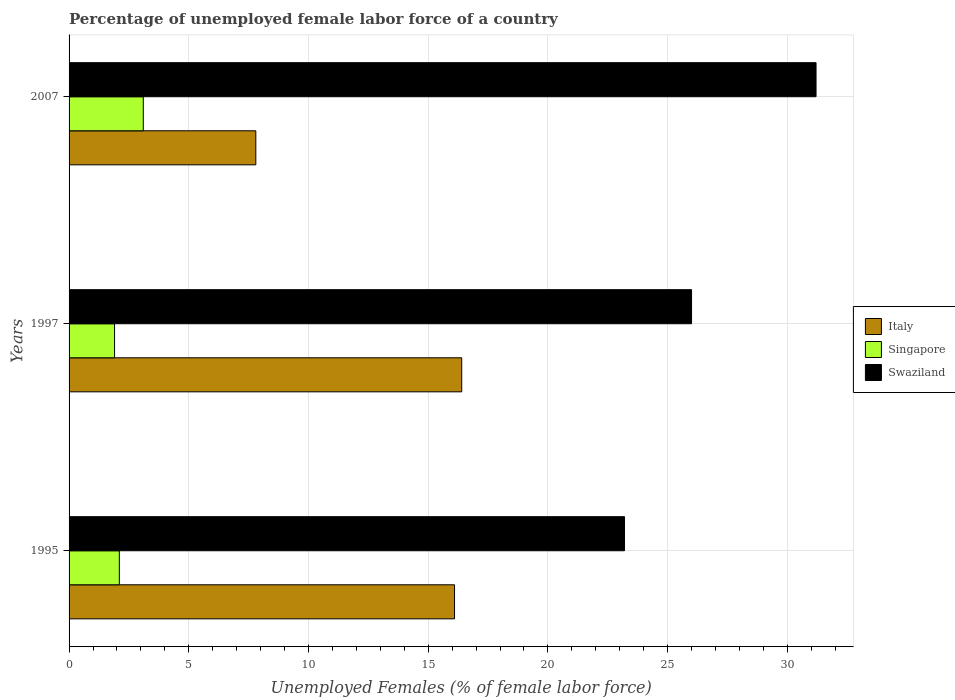How many different coloured bars are there?
Provide a succinct answer. 3. How many groups of bars are there?
Provide a short and direct response. 3. Are the number of bars per tick equal to the number of legend labels?
Make the answer very short. Yes. Are the number of bars on each tick of the Y-axis equal?
Provide a short and direct response. Yes. How many bars are there on the 3rd tick from the bottom?
Your answer should be compact. 3. What is the percentage of unemployed female labor force in Singapore in 1997?
Make the answer very short. 1.9. Across all years, what is the maximum percentage of unemployed female labor force in Swaziland?
Provide a short and direct response. 31.2. Across all years, what is the minimum percentage of unemployed female labor force in Italy?
Make the answer very short. 7.8. What is the total percentage of unemployed female labor force in Singapore in the graph?
Provide a succinct answer. 7.1. What is the difference between the percentage of unemployed female labor force in Italy in 1997 and that in 2007?
Provide a short and direct response. 8.6. What is the difference between the percentage of unemployed female labor force in Swaziland in 2007 and the percentage of unemployed female labor force in Italy in 1995?
Provide a short and direct response. 15.1. What is the average percentage of unemployed female labor force in Swaziland per year?
Your answer should be compact. 26.8. In the year 1995, what is the difference between the percentage of unemployed female labor force in Swaziland and percentage of unemployed female labor force in Singapore?
Give a very brief answer. 21.1. In how many years, is the percentage of unemployed female labor force in Swaziland greater than 17 %?
Provide a succinct answer. 3. What is the ratio of the percentage of unemployed female labor force in Singapore in 1995 to that in 1997?
Offer a very short reply. 1.11. Is the difference between the percentage of unemployed female labor force in Swaziland in 1997 and 2007 greater than the difference between the percentage of unemployed female labor force in Singapore in 1997 and 2007?
Keep it short and to the point. No. What is the difference between the highest and the lowest percentage of unemployed female labor force in Swaziland?
Your answer should be compact. 8. In how many years, is the percentage of unemployed female labor force in Singapore greater than the average percentage of unemployed female labor force in Singapore taken over all years?
Ensure brevity in your answer.  1. Is the sum of the percentage of unemployed female labor force in Singapore in 1995 and 2007 greater than the maximum percentage of unemployed female labor force in Italy across all years?
Offer a terse response. No. What does the 2nd bar from the top in 2007 represents?
Ensure brevity in your answer.  Singapore. What does the 1st bar from the bottom in 2007 represents?
Your answer should be compact. Italy. Is it the case that in every year, the sum of the percentage of unemployed female labor force in Swaziland and percentage of unemployed female labor force in Italy is greater than the percentage of unemployed female labor force in Singapore?
Offer a very short reply. Yes. How many bars are there?
Provide a succinct answer. 9. Are all the bars in the graph horizontal?
Your answer should be compact. Yes. Are the values on the major ticks of X-axis written in scientific E-notation?
Offer a terse response. No. Does the graph contain grids?
Provide a succinct answer. Yes. What is the title of the graph?
Ensure brevity in your answer.  Percentage of unemployed female labor force of a country. Does "Sudan" appear as one of the legend labels in the graph?
Make the answer very short. No. What is the label or title of the X-axis?
Keep it short and to the point. Unemployed Females (% of female labor force). What is the Unemployed Females (% of female labor force) of Italy in 1995?
Your answer should be compact. 16.1. What is the Unemployed Females (% of female labor force) in Singapore in 1995?
Provide a succinct answer. 2.1. What is the Unemployed Females (% of female labor force) of Swaziland in 1995?
Keep it short and to the point. 23.2. What is the Unemployed Females (% of female labor force) of Italy in 1997?
Your response must be concise. 16.4. What is the Unemployed Females (% of female labor force) in Singapore in 1997?
Give a very brief answer. 1.9. What is the Unemployed Females (% of female labor force) of Italy in 2007?
Your response must be concise. 7.8. What is the Unemployed Females (% of female labor force) of Singapore in 2007?
Give a very brief answer. 3.1. What is the Unemployed Females (% of female labor force) in Swaziland in 2007?
Your response must be concise. 31.2. Across all years, what is the maximum Unemployed Females (% of female labor force) of Italy?
Offer a very short reply. 16.4. Across all years, what is the maximum Unemployed Females (% of female labor force) in Singapore?
Provide a succinct answer. 3.1. Across all years, what is the maximum Unemployed Females (% of female labor force) in Swaziland?
Your answer should be compact. 31.2. Across all years, what is the minimum Unemployed Females (% of female labor force) in Italy?
Provide a short and direct response. 7.8. Across all years, what is the minimum Unemployed Females (% of female labor force) in Singapore?
Your answer should be compact. 1.9. Across all years, what is the minimum Unemployed Females (% of female labor force) in Swaziland?
Provide a succinct answer. 23.2. What is the total Unemployed Females (% of female labor force) of Italy in the graph?
Your answer should be compact. 40.3. What is the total Unemployed Females (% of female labor force) of Singapore in the graph?
Ensure brevity in your answer.  7.1. What is the total Unemployed Females (% of female labor force) in Swaziland in the graph?
Your response must be concise. 80.4. What is the difference between the Unemployed Females (% of female labor force) of Italy in 1995 and that in 1997?
Offer a very short reply. -0.3. What is the difference between the Unemployed Females (% of female labor force) of Singapore in 1995 and that in 1997?
Offer a terse response. 0.2. What is the difference between the Unemployed Females (% of female labor force) of Italy in 1997 and that in 2007?
Provide a short and direct response. 8.6. What is the difference between the Unemployed Females (% of female labor force) in Singapore in 1997 and that in 2007?
Your answer should be very brief. -1.2. What is the difference between the Unemployed Females (% of female labor force) in Singapore in 1995 and the Unemployed Females (% of female labor force) in Swaziland in 1997?
Ensure brevity in your answer.  -23.9. What is the difference between the Unemployed Females (% of female labor force) of Italy in 1995 and the Unemployed Females (% of female labor force) of Swaziland in 2007?
Offer a terse response. -15.1. What is the difference between the Unemployed Females (% of female labor force) in Singapore in 1995 and the Unemployed Females (% of female labor force) in Swaziland in 2007?
Provide a short and direct response. -29.1. What is the difference between the Unemployed Females (% of female labor force) in Italy in 1997 and the Unemployed Females (% of female labor force) in Singapore in 2007?
Offer a terse response. 13.3. What is the difference between the Unemployed Females (% of female labor force) in Italy in 1997 and the Unemployed Females (% of female labor force) in Swaziland in 2007?
Offer a very short reply. -14.8. What is the difference between the Unemployed Females (% of female labor force) in Singapore in 1997 and the Unemployed Females (% of female labor force) in Swaziland in 2007?
Your answer should be very brief. -29.3. What is the average Unemployed Females (% of female labor force) of Italy per year?
Offer a terse response. 13.43. What is the average Unemployed Females (% of female labor force) in Singapore per year?
Ensure brevity in your answer.  2.37. What is the average Unemployed Females (% of female labor force) of Swaziland per year?
Your answer should be compact. 26.8. In the year 1995, what is the difference between the Unemployed Females (% of female labor force) of Italy and Unemployed Females (% of female labor force) of Swaziland?
Your answer should be compact. -7.1. In the year 1995, what is the difference between the Unemployed Females (% of female labor force) in Singapore and Unemployed Females (% of female labor force) in Swaziland?
Offer a terse response. -21.1. In the year 1997, what is the difference between the Unemployed Females (% of female labor force) of Italy and Unemployed Females (% of female labor force) of Singapore?
Provide a short and direct response. 14.5. In the year 1997, what is the difference between the Unemployed Females (% of female labor force) in Italy and Unemployed Females (% of female labor force) in Swaziland?
Offer a terse response. -9.6. In the year 1997, what is the difference between the Unemployed Females (% of female labor force) of Singapore and Unemployed Females (% of female labor force) of Swaziland?
Your answer should be very brief. -24.1. In the year 2007, what is the difference between the Unemployed Females (% of female labor force) in Italy and Unemployed Females (% of female labor force) in Singapore?
Offer a terse response. 4.7. In the year 2007, what is the difference between the Unemployed Females (% of female labor force) in Italy and Unemployed Females (% of female labor force) in Swaziland?
Your response must be concise. -23.4. In the year 2007, what is the difference between the Unemployed Females (% of female labor force) in Singapore and Unemployed Females (% of female labor force) in Swaziland?
Provide a succinct answer. -28.1. What is the ratio of the Unemployed Females (% of female labor force) in Italy in 1995 to that in 1997?
Ensure brevity in your answer.  0.98. What is the ratio of the Unemployed Females (% of female labor force) of Singapore in 1995 to that in 1997?
Your response must be concise. 1.11. What is the ratio of the Unemployed Females (% of female labor force) of Swaziland in 1995 to that in 1997?
Give a very brief answer. 0.89. What is the ratio of the Unemployed Females (% of female labor force) of Italy in 1995 to that in 2007?
Your answer should be very brief. 2.06. What is the ratio of the Unemployed Females (% of female labor force) of Singapore in 1995 to that in 2007?
Your answer should be compact. 0.68. What is the ratio of the Unemployed Females (% of female labor force) of Swaziland in 1995 to that in 2007?
Your response must be concise. 0.74. What is the ratio of the Unemployed Females (% of female labor force) in Italy in 1997 to that in 2007?
Ensure brevity in your answer.  2.1. What is the ratio of the Unemployed Females (% of female labor force) of Singapore in 1997 to that in 2007?
Keep it short and to the point. 0.61. What is the difference between the highest and the second highest Unemployed Females (% of female labor force) in Singapore?
Keep it short and to the point. 1. What is the difference between the highest and the lowest Unemployed Females (% of female labor force) in Italy?
Offer a terse response. 8.6. What is the difference between the highest and the lowest Unemployed Females (% of female labor force) in Swaziland?
Your answer should be compact. 8. 